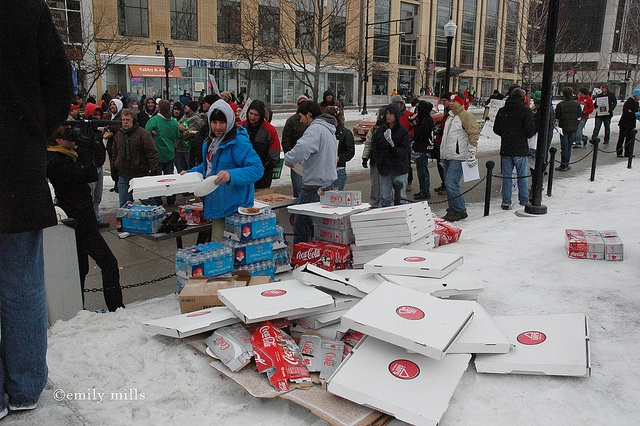Describe the objects in this image and their specific colors. I can see people in black, gray, darkgray, and navy tones, people in black, blue, and navy tones, bottle in black, gray, and teal tones, people in black, gray, and darkgray tones, and people in black, gray, navy, and blue tones in this image. 